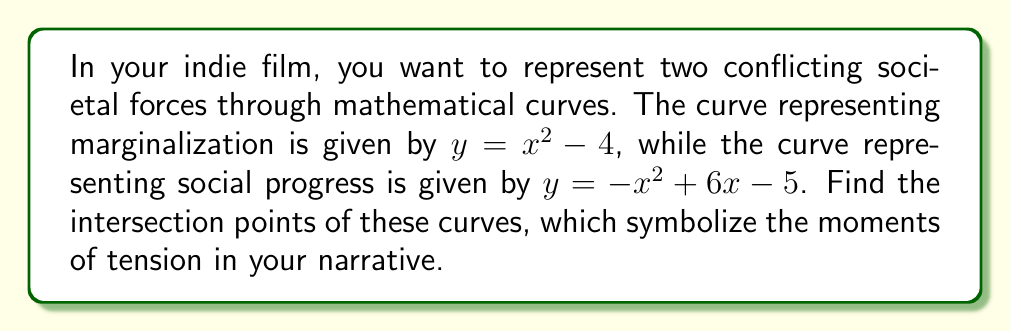Can you answer this question? To find the intersection points, we need to solve the equation:

$x^2 - 4 = -x^2 + 6x - 5$

1) First, let's rearrange the equation:
   $x^2 - 4 = -x^2 + 6x - 5$
   $x^2 + (-x^2 + 6x - 5) = -4$
   $2x^2 - 6x + 1 = 0$

2) This is a quadratic equation. We can solve it using the quadratic formula:
   $x = \frac{-b \pm \sqrt{b^2 - 4ac}}{2a}$

   Where $a = 2$, $b = -6$, and $c = 1$

3) Substituting these values:
   $x = \frac{6 \pm \sqrt{(-6)^2 - 4(2)(1)}}{2(2)}$
   $x = \frac{6 \pm \sqrt{36 - 8}}{4}$
   $x = \frac{6 \pm \sqrt{28}}{4}$
   $x = \frac{6 \pm 2\sqrt{7}}{4}$

4) Simplifying:
   $x = \frac{3 \pm \sqrt{7}}{2}$

5) This gives us two x-coordinates:
   $x_1 = \frac{3 + \sqrt{7}}{2}$ and $x_2 = \frac{3 - \sqrt{7}}{2}$

6) To find the y-coordinates, we can substitute either x value into either of the original equations. Let's use $y = x^2 - 4$:

   For $x_1$: $y_1 = (\frac{3 + \sqrt{7}}{2})^2 - 4$
   For $x_2$: $y_2 = (\frac{3 - \sqrt{7}}{2})^2 - 4$

7) Simplifying these expressions (which are equal):
   $y_1 = y_2 = \frac{9 + 7}{4} - 4 = \frac{16}{4} - 4 = 0$

Therefore, the intersection points are $(\frac{3 + \sqrt{7}}{2}, 0)$ and $(\frac{3 - \sqrt{7}}{2}, 0)$.
Answer: $(\frac{3 + \sqrt{7}}{2}, 0)$ and $(\frac{3 - \sqrt{7}}{2}, 0)$ 